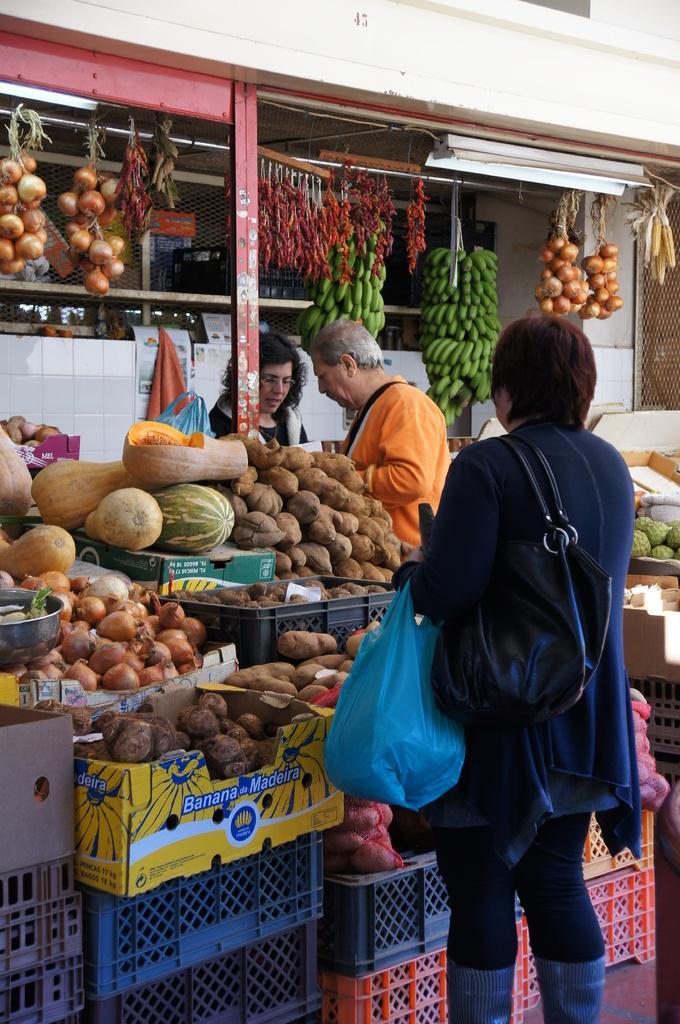Describe this image in one or two sentences. In this image we can see three persons, one of them is holding a cover, she is wearing a bag, there are vegetables in the baskets, and some vegetables are on the boxes, there are some vegetables hung to the rods, there is a house, and lights, also we can see some other baskets. 